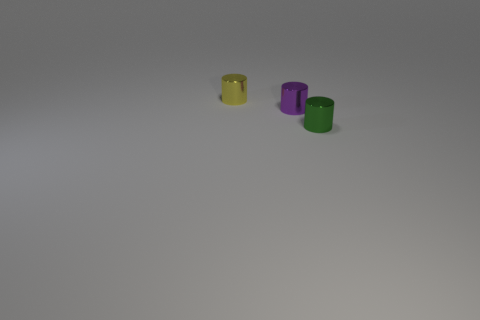Are there more small metallic things to the left of the tiny green thing than small purple cylinders right of the yellow thing?
Offer a terse response. Yes. How many cubes are either cyan matte things or yellow metal objects?
Offer a very short reply. 0. There is a yellow object behind the small purple metallic thing; does it have the same shape as the small purple shiny thing?
Make the answer very short. Yes. How many other tiny green objects are the same shape as the green object?
Provide a short and direct response. 0. How many objects are purple metal objects or tiny cylinders that are in front of the small purple object?
Make the answer very short. 2. There is a shiny cylinder that is to the right of the small yellow cylinder and left of the tiny green cylinder; what is its size?
Provide a succinct answer. Small. There is a small purple shiny cylinder; are there any small green things behind it?
Make the answer very short. No. There is a object on the left side of the purple metallic cylinder; is there a purple cylinder that is in front of it?
Provide a short and direct response. Yes. Is the number of purple cylinders that are to the right of the yellow metal cylinder the same as the number of green objects that are behind the tiny green cylinder?
Provide a succinct answer. No. Is there a purple cylinder made of the same material as the green thing?
Your answer should be compact. Yes. 